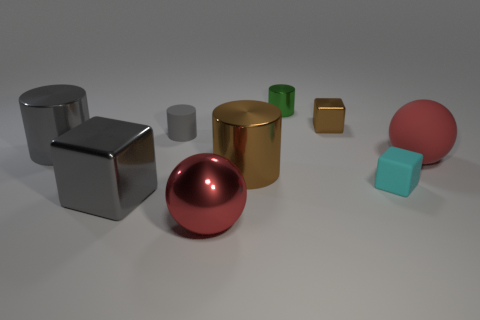What is the size of the rubber cylinder that is the same color as the big block?
Provide a short and direct response. Small. Do the large shiny ball and the big object right of the green cylinder have the same color?
Your answer should be very brief. Yes. There is a gray matte thing; is its size the same as the red thing right of the small cyan cube?
Offer a terse response. No. How many blocks are large cyan objects or red things?
Offer a terse response. 0. What number of large metal things are both on the left side of the red metal thing and behind the cyan matte thing?
Ensure brevity in your answer.  1. How many other things are there of the same color as the tiny metal cube?
Provide a succinct answer. 1. What is the shape of the big brown thing that is behind the big shiny block?
Your answer should be compact. Cylinder. Does the tiny brown thing have the same material as the cyan block?
Give a very brief answer. No. There is a small brown block; what number of cylinders are behind it?
Your answer should be very brief. 1. What is the shape of the red object that is to the left of the tiny block that is in front of the brown cube?
Keep it short and to the point. Sphere. 